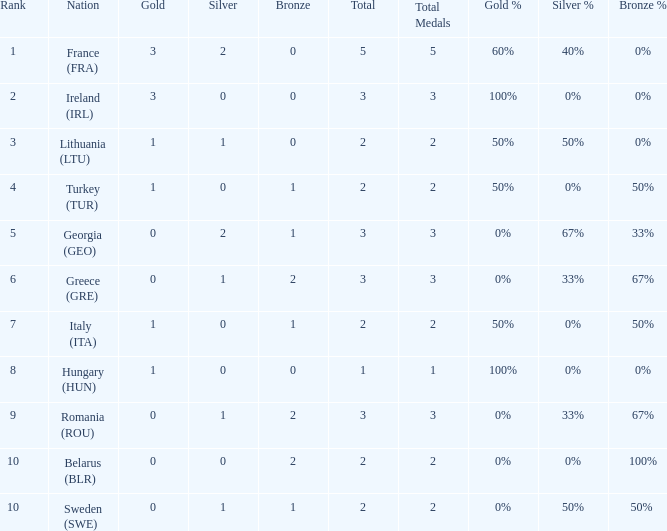What's the total when the gold is less than 0 and silver is less than 1? None. 